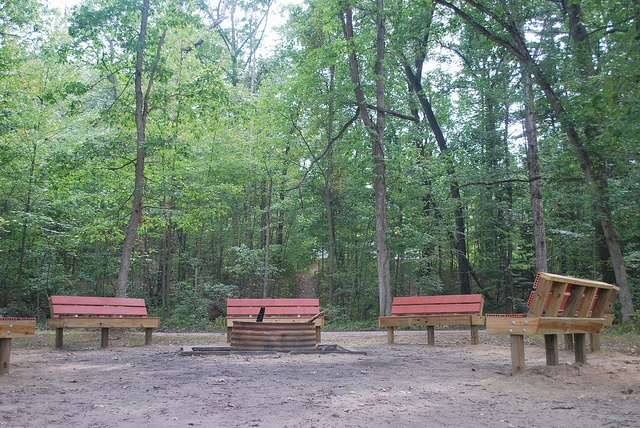Describe the objects in this image and their specific colors. I can see bench in lightgreen, gray, and maroon tones, bench in lightgreen, gray, and lightpink tones, bench in lightgreen, salmon, gray, and maroon tones, bench in lightgreen, lightpink, salmon, gray, and darkgray tones, and bench in lightgreen, gray, and black tones in this image. 